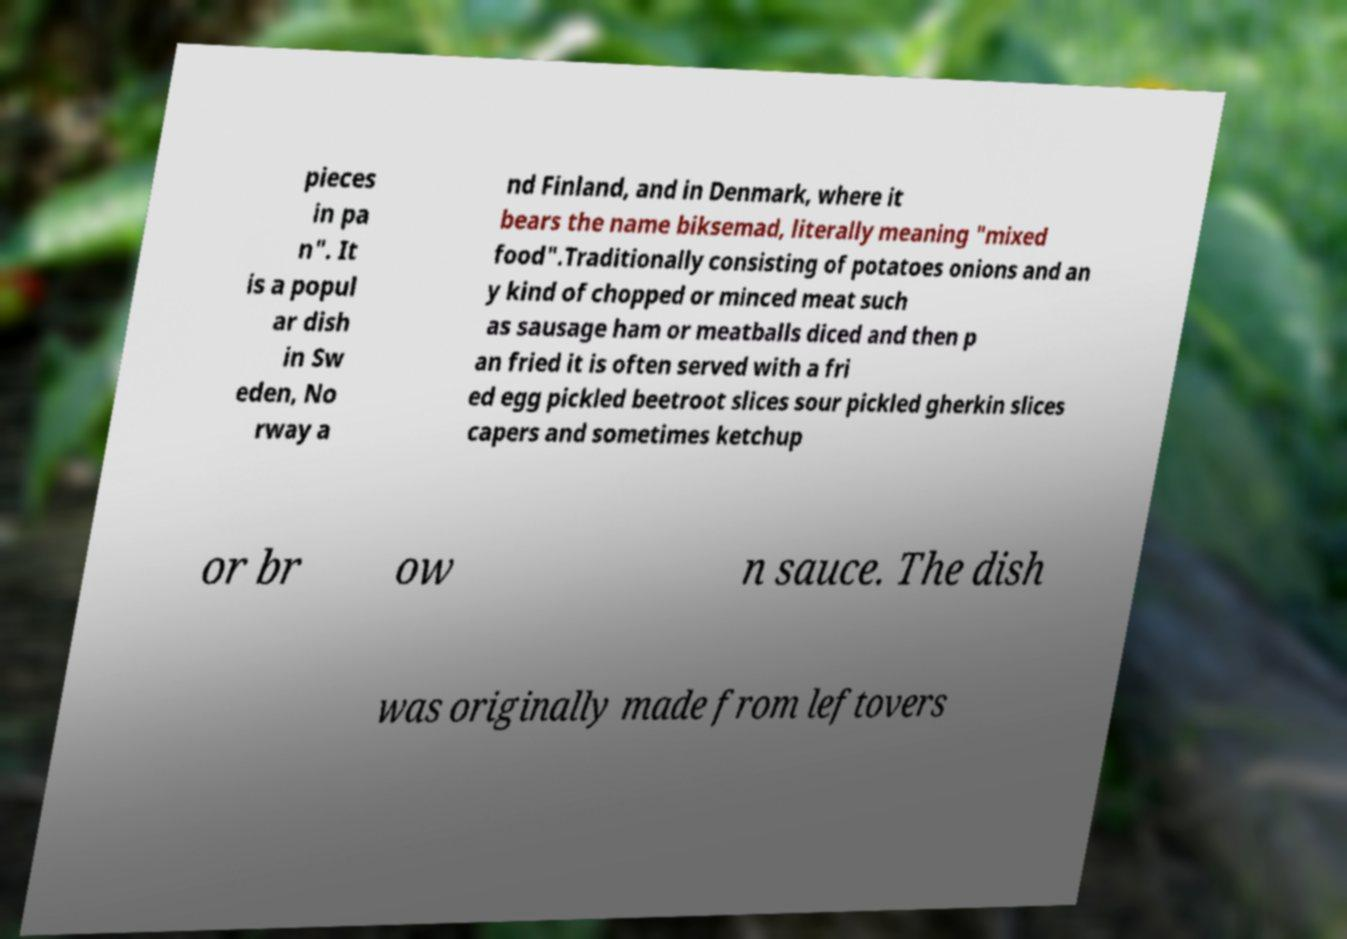What messages or text are displayed in this image? I need them in a readable, typed format. pieces in pa n". It is a popul ar dish in Sw eden, No rway a nd Finland, and in Denmark, where it bears the name biksemad, literally meaning "mixed food".Traditionally consisting of potatoes onions and an y kind of chopped or minced meat such as sausage ham or meatballs diced and then p an fried it is often served with a fri ed egg pickled beetroot slices sour pickled gherkin slices capers and sometimes ketchup or br ow n sauce. The dish was originally made from leftovers 